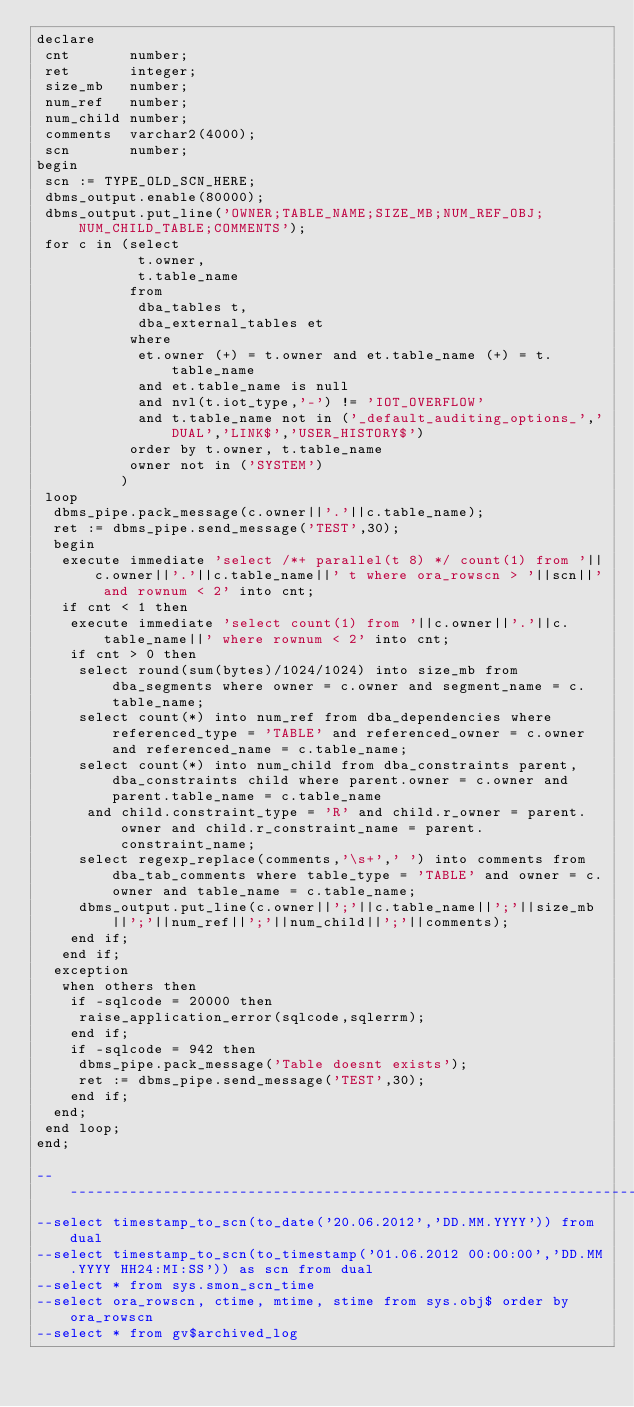Convert code to text. <code><loc_0><loc_0><loc_500><loc_500><_SQL_>declare
 cnt       number;
 ret       integer;
 size_mb   number;
 num_ref   number;
 num_child number;
 comments  varchar2(4000);
 scn       number;
begin
 scn := TYPE_OLD_SCN_HERE;
 dbms_output.enable(80000);
 dbms_output.put_line('OWNER;TABLE_NAME;SIZE_MB;NUM_REF_OBJ;NUM_CHILD_TABLE;COMMENTS');
 for c in (select
            t.owner,
            t.table_name
           from
            dba_tables t,
            dba_external_tables et
           where
            et.owner (+) = t.owner and et.table_name (+) = t.table_name
            and et.table_name is null
            and nvl(t.iot_type,'-') != 'IOT_OVERFLOW'
            and t.table_name not in ('_default_auditing_options_','DUAL','LINK$','USER_HISTORY$')
           order by t.owner, t.table_name
           owner not in ('SYSTEM')
          )
 loop
  dbms_pipe.pack_message(c.owner||'.'||c.table_name);
  ret := dbms_pipe.send_message('TEST',30);
  begin
   execute immediate 'select /*+ parallel(t 8) */ count(1) from '||c.owner||'.'||c.table_name||' t where ora_rowscn > '||scn||' and rownum < 2' into cnt;
   if cnt < 1 then
    execute immediate 'select count(1) from '||c.owner||'.'||c.table_name||' where rownum < 2' into cnt;
    if cnt > 0 then
     select round(sum(bytes)/1024/1024) into size_mb from dba_segments where owner = c.owner and segment_name = c.table_name;
     select count(*) into num_ref from dba_dependencies where referenced_type = 'TABLE' and referenced_owner = c.owner and referenced_name = c.table_name;
     select count(*) into num_child from dba_constraints parent, dba_constraints child where parent.owner = c.owner and parent.table_name = c.table_name
      and child.constraint_type = 'R' and child.r_owner = parent.owner and child.r_constraint_name = parent.constraint_name;
     select regexp_replace(comments,'\s+',' ') into comments from dba_tab_comments where table_type = 'TABLE' and owner = c.owner and table_name = c.table_name;
     dbms_output.put_line(c.owner||';'||c.table_name||';'||size_mb||';'||num_ref||';'||num_child||';'||comments);
    end if;
   end if;
  exception
   when others then
    if -sqlcode = 20000 then
     raise_application_error(sqlcode,sqlerrm);
    end if;
    if -sqlcode = 942 then
     dbms_pipe.pack_message('Table doesnt exists');
     ret := dbms_pipe.send_message('TEST',30);
    end if;
  end;
 end loop;
end;

-----------------------------------------------------------------------------------------------------------------------------
--select timestamp_to_scn(to_date('20.06.2012','DD.MM.YYYY')) from dual
--select timestamp_to_scn(to_timestamp('01.06.2012 00:00:00','DD.MM.YYYY HH24:MI:SS')) as scn from dual
--select * from sys.smon_scn_time
--select ora_rowscn, ctime, mtime, stime from sys.obj$ order by ora_rowscn
--select * from gv$archived_log
</code> 